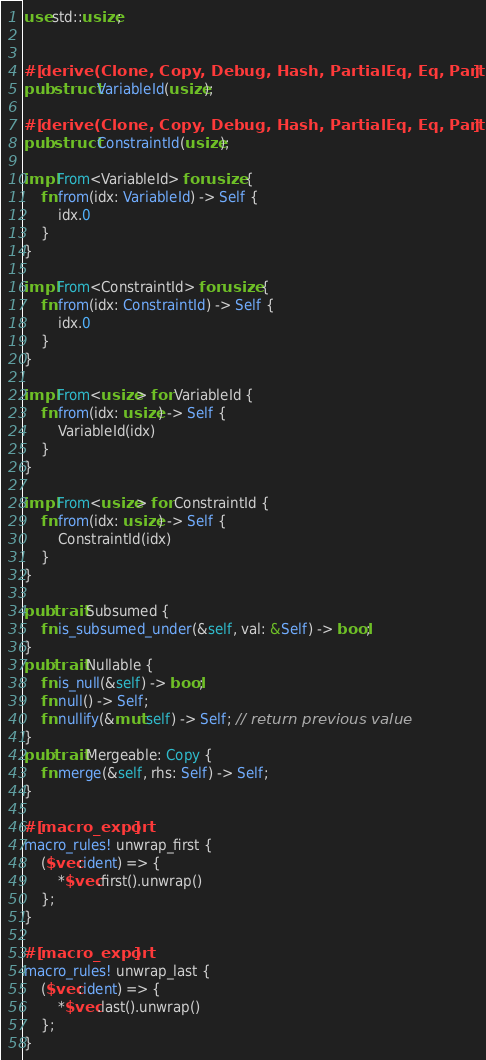Convert code to text. <code><loc_0><loc_0><loc_500><loc_500><_Rust_>use std::usize;


#[derive(Clone, Copy, Debug, Hash, PartialEq, Eq, PartialOrd, Ord)]
pub struct VariableId(usize);

#[derive(Clone, Copy, Debug, Hash, PartialEq, Eq, PartialOrd, Ord)]
pub struct ConstraintId(usize);

impl From<VariableId> for usize {
    fn from(idx: VariableId) -> Self {
        idx.0
    }
}

impl From<ConstraintId> for usize {
    fn from(idx: ConstraintId) -> Self {
        idx.0
    }
}

impl From<usize> for VariableId {
    fn from(idx: usize) -> Self {
        VariableId(idx)
    }
}

impl From<usize> for ConstraintId {
    fn from(idx: usize) -> Self {
        ConstraintId(idx)
    }
}

pub trait Subsumed {
    fn is_subsumed_under(&self, val: &Self) -> bool;
}
pub trait Nullable {
    fn is_null(&self) -> bool;
    fn null() -> Self;
    fn nullify(&mut self) -> Self; // return previous value
}
pub trait Mergeable: Copy {
    fn merge(&self, rhs: Self) -> Self;
}

#[macro_export]
macro_rules! unwrap_first {
    ($vec:ident) => {
        *$vec.first().unwrap()
    };
}

#[macro_export]
macro_rules! unwrap_last {
    ($vec:ident) => {
        *$vec.last().unwrap()
    };
}
</code> 